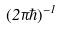Convert formula to latex. <formula><loc_0><loc_0><loc_500><loc_500>( 2 \pi \hbar { ) } ^ { - 1 }</formula> 